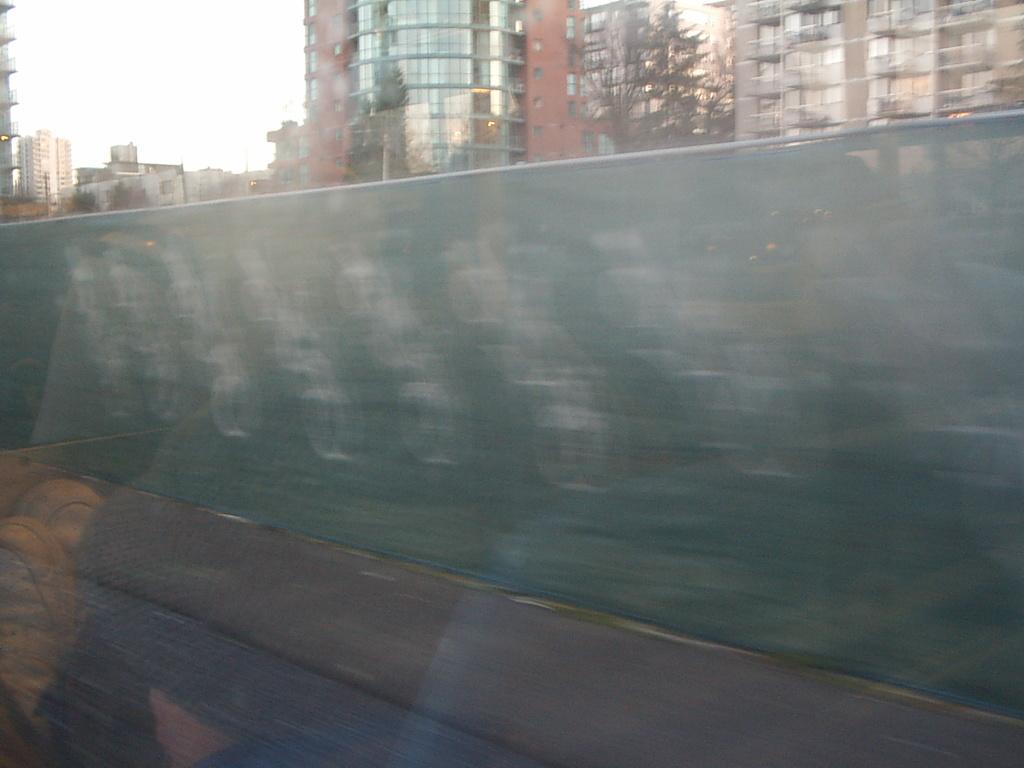In one or two sentences, can you explain what this image depicts? On the left side, there is a road, near footpath. Which is near a sheet. In the background, there are trees, buildings. Which are having glass windows and there is sky. 